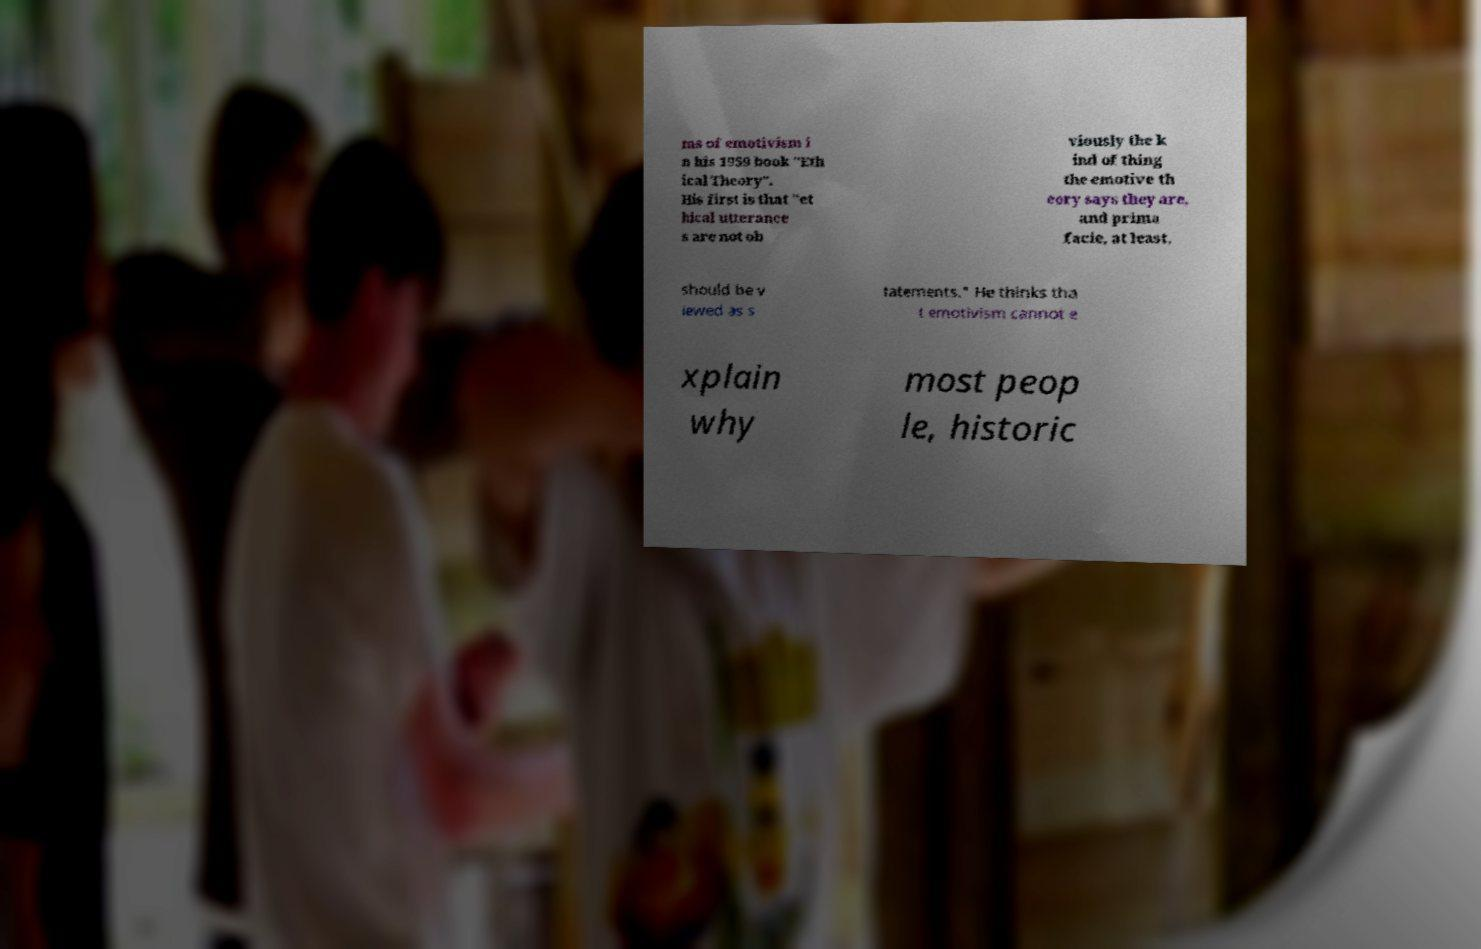I need the written content from this picture converted into text. Can you do that? ms of emotivism i n his 1959 book "Eth ical Theory". His first is that "et hical utterance s are not ob viously the k ind of thing the emotive th eory says they are, and prima facie, at least, should be v iewed as s tatements." He thinks tha t emotivism cannot e xplain why most peop le, historic 